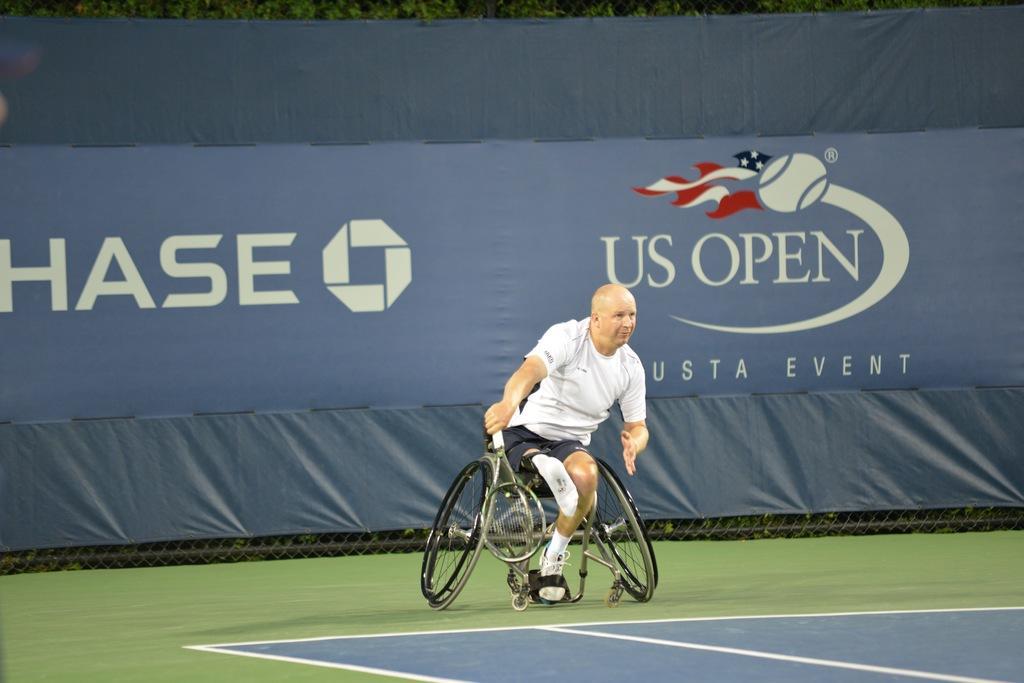In one or two sentences, can you explain what this image depicts? In the middle, a person is sitting on the wheelchair. The background is covered with curtain of grey and blue in color. At the bottom, green color pitch is there. On the top trees are visible. This image is taken on the ground. 